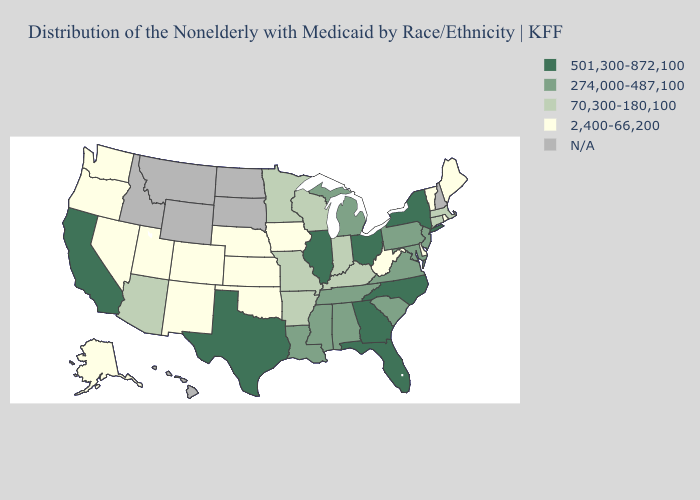What is the value of Louisiana?
Quick response, please. 274,000-487,100. What is the highest value in the USA?
Be succinct. 501,300-872,100. What is the lowest value in the West?
Give a very brief answer. 2,400-66,200. What is the lowest value in the MidWest?
Be succinct. 2,400-66,200. How many symbols are there in the legend?
Give a very brief answer. 5. How many symbols are there in the legend?
Be succinct. 5. Name the states that have a value in the range 274,000-487,100?
Concise answer only. Alabama, Louisiana, Maryland, Michigan, Mississippi, New Jersey, Pennsylvania, South Carolina, Tennessee, Virginia. Name the states that have a value in the range 274,000-487,100?
Be succinct. Alabama, Louisiana, Maryland, Michigan, Mississippi, New Jersey, Pennsylvania, South Carolina, Tennessee, Virginia. Does the map have missing data?
Keep it brief. Yes. What is the highest value in the USA?
Short answer required. 501,300-872,100. What is the highest value in the USA?
Be succinct. 501,300-872,100. What is the highest value in the USA?
Concise answer only. 501,300-872,100. What is the value of New York?
Quick response, please. 501,300-872,100. Name the states that have a value in the range 274,000-487,100?
Short answer required. Alabama, Louisiana, Maryland, Michigan, Mississippi, New Jersey, Pennsylvania, South Carolina, Tennessee, Virginia. 